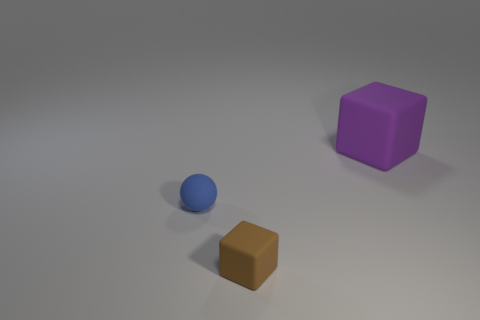What number of objects are either small matte objects or purple matte objects?
Provide a succinct answer. 3. There is a rubber object on the right side of the rubber block that is on the left side of the rubber object that is on the right side of the tiny cube; what shape is it?
Your answer should be compact. Cube. Is the material of the block in front of the large rubber object the same as the thing that is to the right of the tiny brown object?
Provide a succinct answer. Yes. There is another thing that is the same shape as the tiny brown thing; what material is it?
Keep it short and to the point. Rubber. Are there any other things that have the same size as the purple rubber thing?
Offer a terse response. No. Is the shape of the tiny rubber thing that is in front of the ball the same as the matte object that is behind the tiny blue sphere?
Keep it short and to the point. Yes. Is the number of large rubber objects that are in front of the blue matte thing less than the number of blue matte spheres that are on the left side of the brown matte thing?
Your answer should be very brief. Yes. How many other things are there of the same shape as the tiny blue matte thing?
Offer a very short reply. 0. There is a small object that is the same material as the tiny brown block; what shape is it?
Keep it short and to the point. Sphere. What color is the matte thing that is both to the right of the blue rubber sphere and behind the brown matte thing?
Give a very brief answer. Purple. 